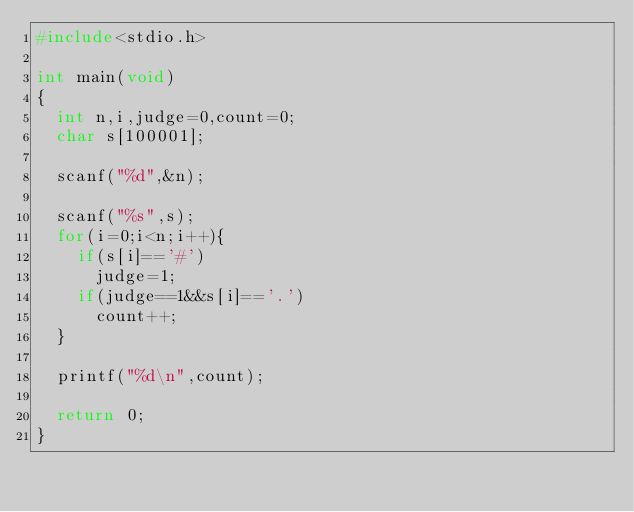Convert code to text. <code><loc_0><loc_0><loc_500><loc_500><_C_>#include<stdio.h>

int main(void)
{
  int n,i,judge=0,count=0;
  char s[100001];
  
  scanf("%d",&n);
  
  scanf("%s",s);
  for(i=0;i<n;i++){
    if(s[i]=='#')
      judge=1;
    if(judge==1&&s[i]=='.')
      count++;
  }
  
  printf("%d\n",count);
  
  return 0;
}</code> 